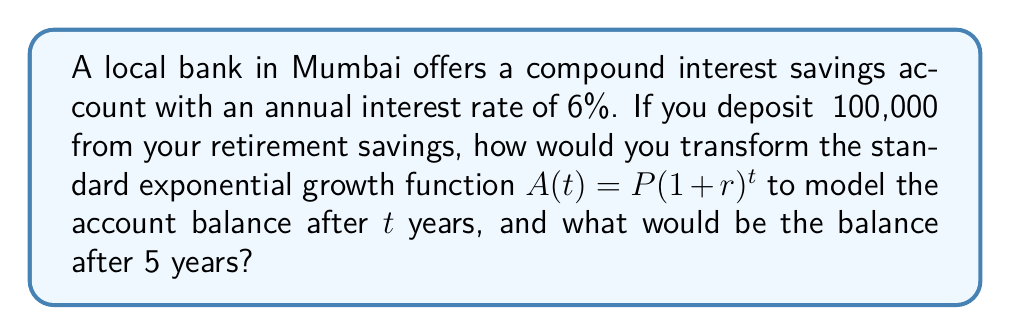Help me with this question. To solve this problem, we'll follow these steps:

1) The standard exponential growth function is:
   $A(t) = P(1 + r)^t$
   Where:
   $A(t)$ is the amount after time $t$
   $P$ is the principal (initial investment)
   $r$ is the annual interest rate (as a decimal)
   $t$ is the time in years

2) We need to transform this function with our given values:
   $P = ₹100,000$
   $r = 6\% = 0.06$

3) Substituting these values into the function:
   $A(t) = 100000(1 + 0.06)^t$

4) Simplify inside the parentheses:
   $A(t) = 100000(1.06)^t$

5) This is our transformed function to model the account balance after $t$ years.

6) To find the balance after 5 years, we substitute $t = 5$:
   $A(5) = 100000(1.06)^5$

7) Calculate:
   $A(5) = 100000 * 1.33823069$
   $A(5) = 133823.069$

8) Rounding to the nearest rupee:
   $A(5) = ₹133,823$
Answer: $A(t) = 100000(1.06)^t$; ₹133,823 after 5 years 